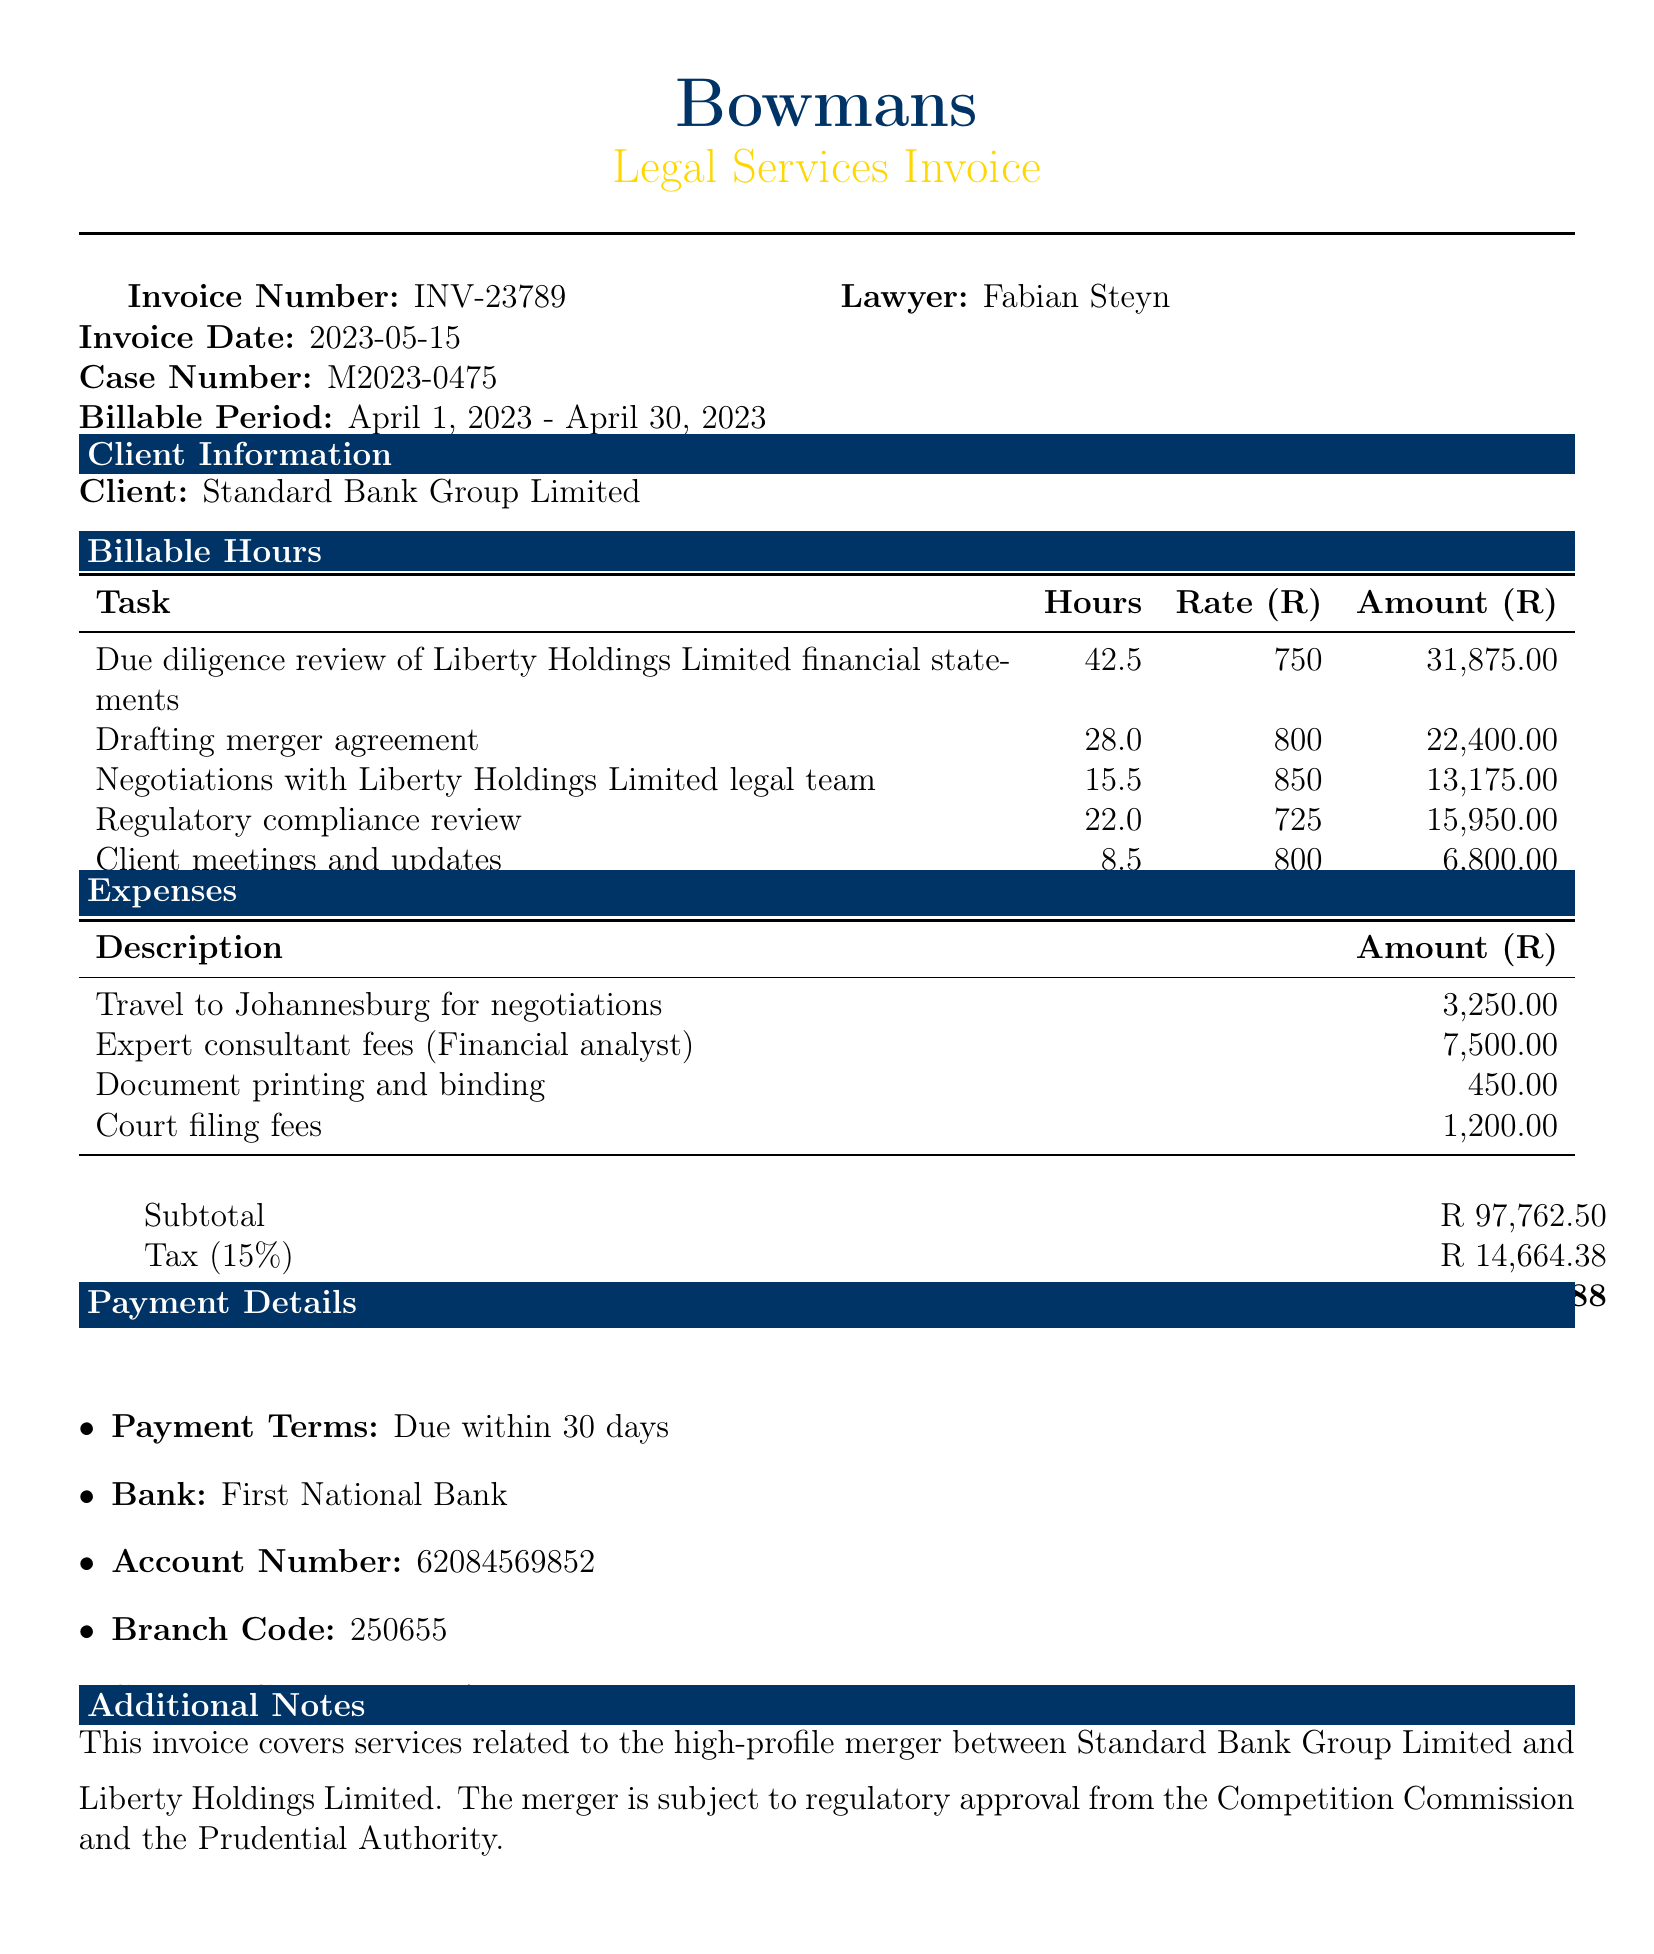What is the invoice number? The invoice number is clearly stated in the document, which is INV-23789.
Answer: INV-23789 Who is the client company? The client company involved in the merger is specified in the document.
Answer: Standard Bank Group Limited What is the total amount due? The total due amount is provided at the end of the invoice section.
Answer: R 112,426.88 How many hours were billed for drafting the merger agreement? The number of hours for this specific task is listed under the billable hours section.
Answer: 28.0 What is the tax rate applied to the invoice? The tax rate can be found in the financial details portion of the document.
Answer: 15% What was the task with the highest billed hours? The task with the highest number of billable hours requires comparing billable hours entries.
Answer: Due diligence review of Liberty Holdings Limited financial statements What is the payment term specified in the invoice? The payment terms are detailed in the payment details section of the document.
Answer: Due within 30 days What is the amount for travel expenses? The travel expense amount is listed under the expenses section.
Answer: R 3,250.00 What was the main case described in the invoice? The primary case description is included in the client information section.
Answer: Corporate merger between Standard Bank Group Limited and Liberty Holdings Limited 